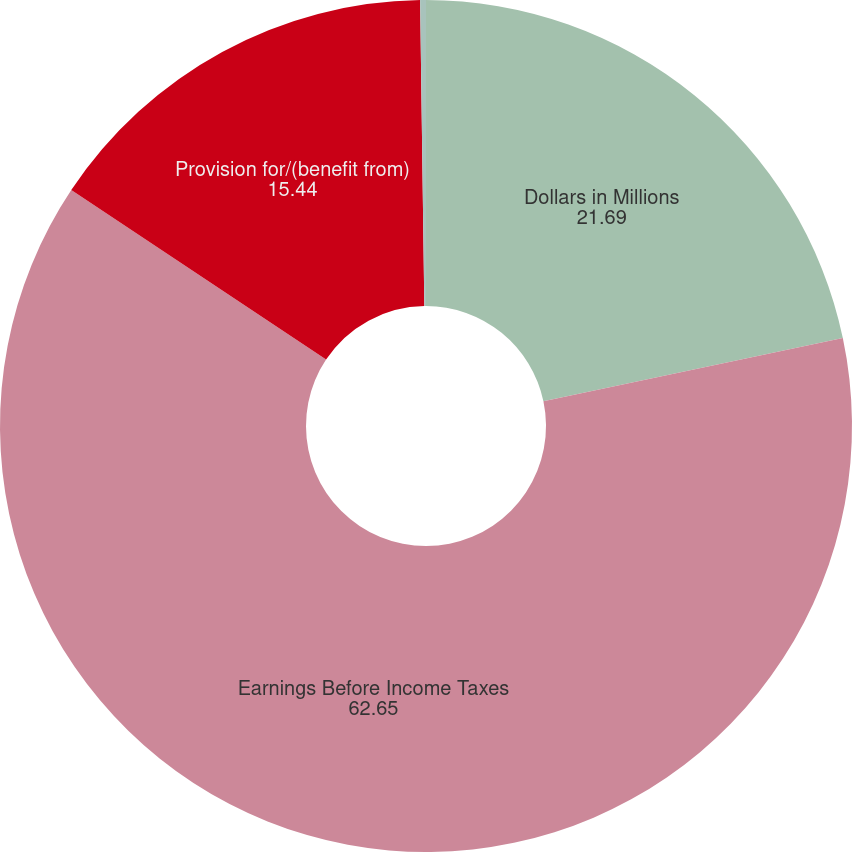<chart> <loc_0><loc_0><loc_500><loc_500><pie_chart><fcel>Dollars in Millions<fcel>Earnings Before Income Taxes<fcel>Provision for/(benefit from)<fcel>Effective tax/(benefit) rate<nl><fcel>21.69%<fcel>62.65%<fcel>15.44%<fcel>0.22%<nl></chart> 